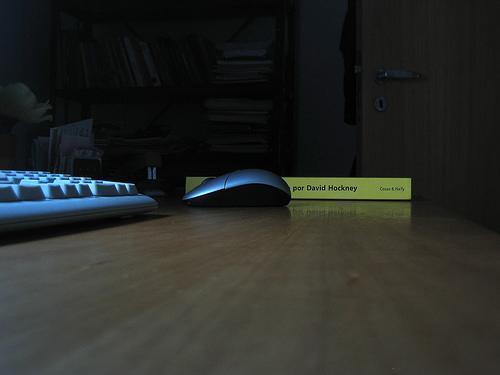How many light green color books are on the table?
Give a very brief answer. 1. 